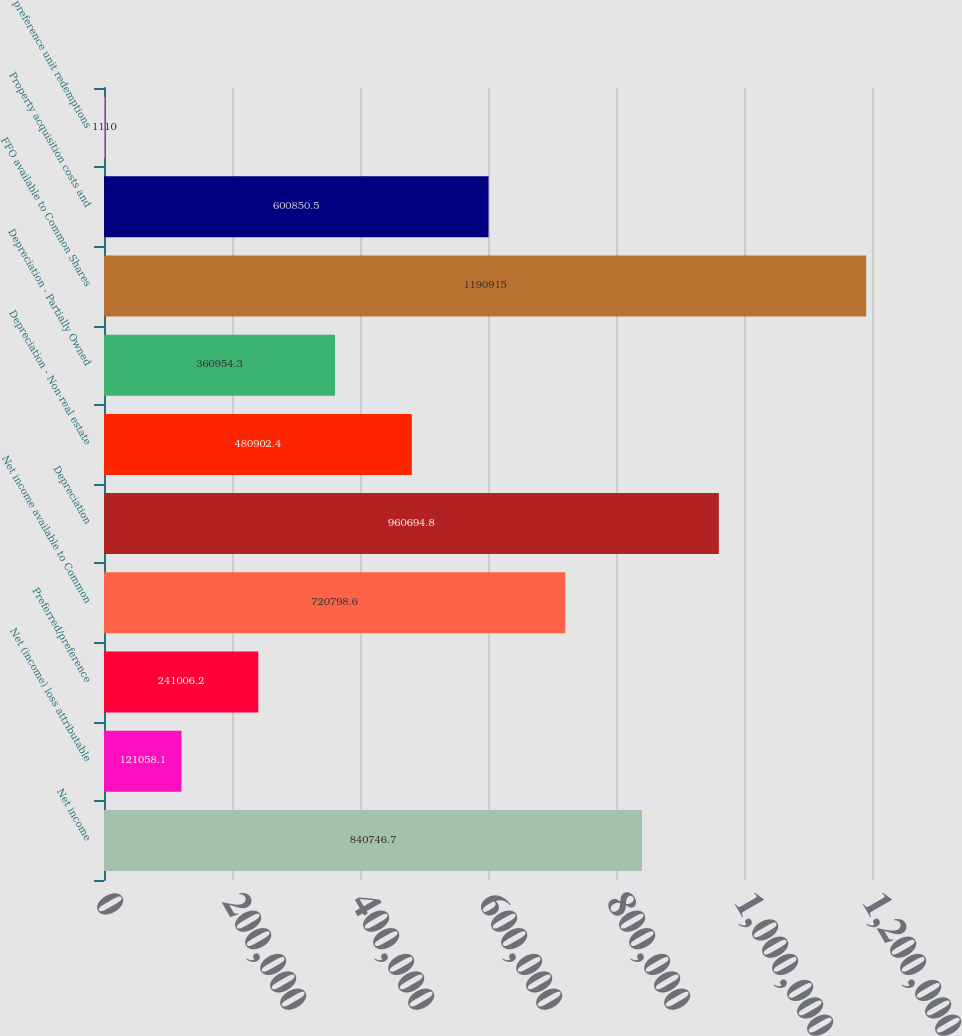<chart> <loc_0><loc_0><loc_500><loc_500><bar_chart><fcel>Net income<fcel>Net (income) loss attributable<fcel>Preferred/preference<fcel>Net income available to Common<fcel>Depreciation<fcel>Depreciation - Non-real estate<fcel>Depreciation - Partially Owned<fcel>FFO available to Common Shares<fcel>Property acquisition costs and<fcel>preference unit redemptions<nl><fcel>840747<fcel>121058<fcel>241006<fcel>720799<fcel>960695<fcel>480902<fcel>360954<fcel>1.19092e+06<fcel>600850<fcel>1110<nl></chart> 